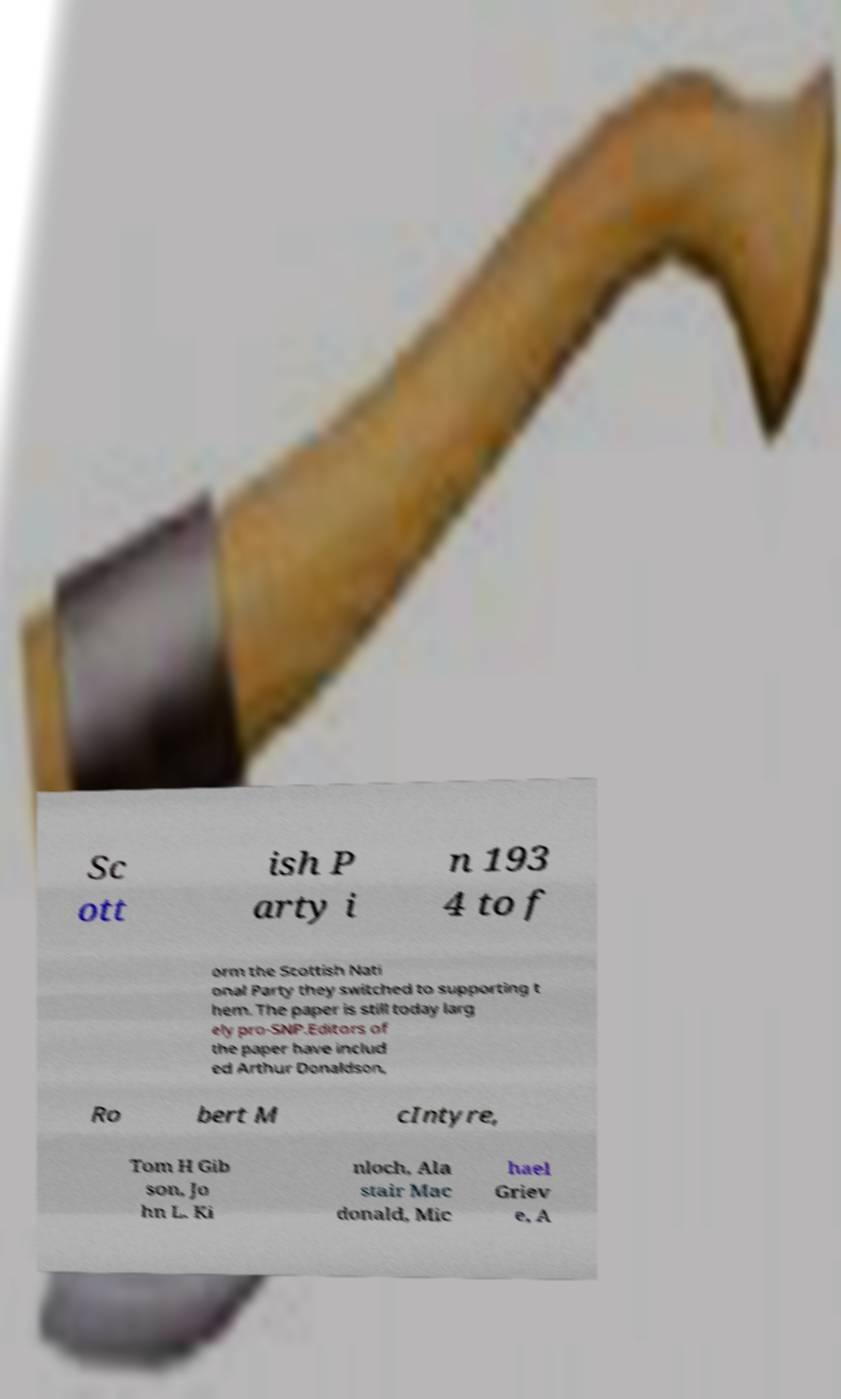Could you extract and type out the text from this image? Sc ott ish P arty i n 193 4 to f orm the Scottish Nati onal Party they switched to supporting t hem. The paper is still today larg ely pro-SNP.Editors of the paper have includ ed Arthur Donaldson, Ro bert M cIntyre, Tom H Gib son, Jo hn L. Ki nloch, Ala stair Mac donald, Mic hael Griev e, A 